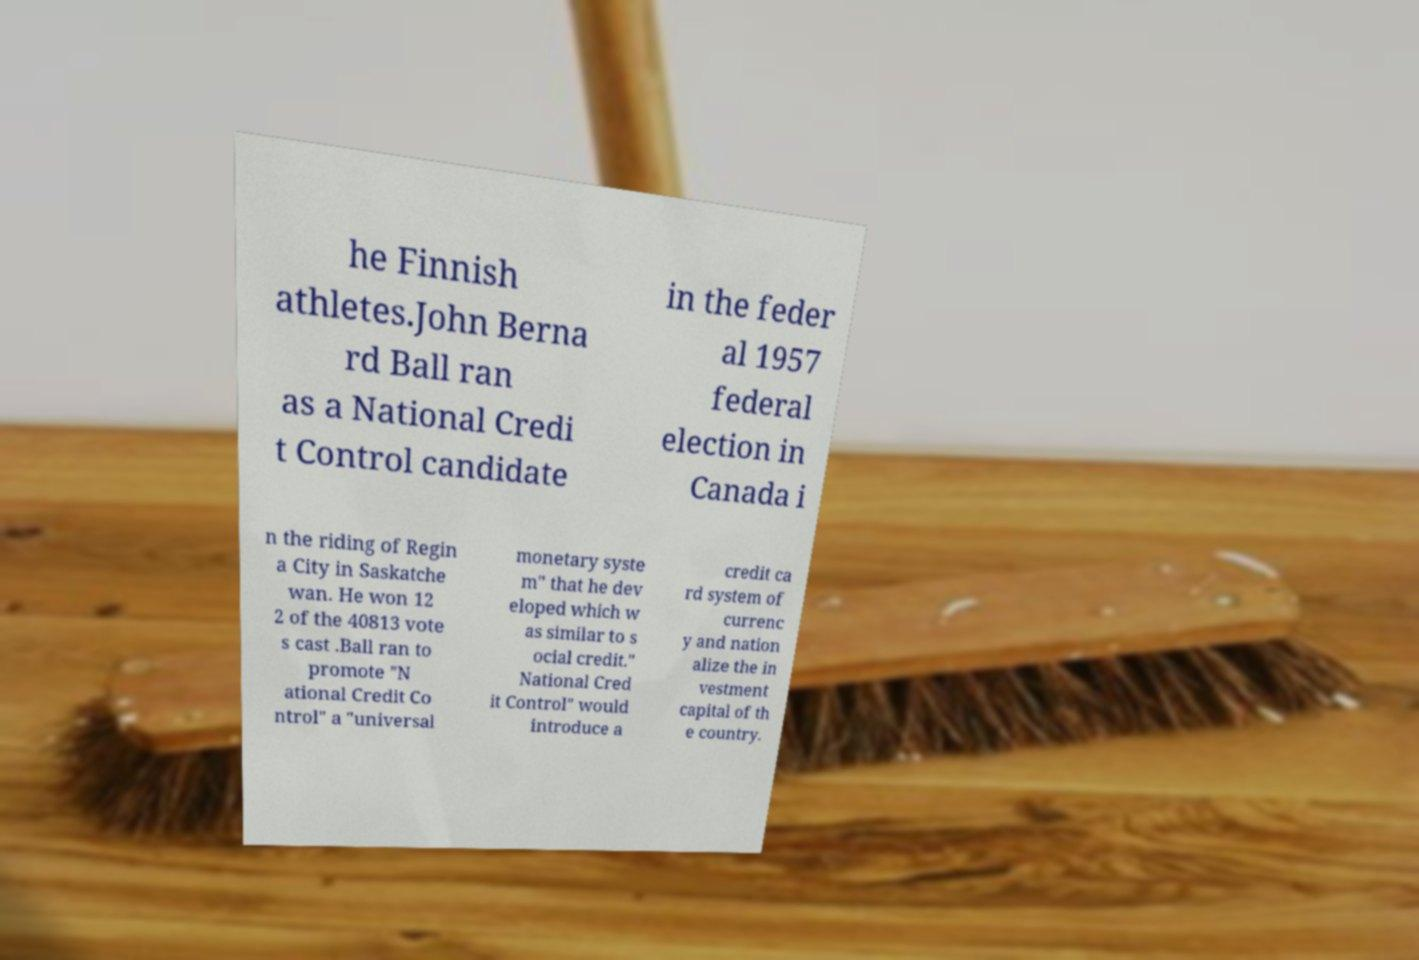There's text embedded in this image that I need extracted. Can you transcribe it verbatim? he Finnish athletes.John Berna rd Ball ran as a National Credi t Control candidate in the feder al 1957 federal election in Canada i n the riding of Regin a City in Saskatche wan. He won 12 2 of the 40813 vote s cast .Ball ran to promote "N ational Credit Co ntrol" a "universal monetary syste m" that he dev eloped which w as similar to s ocial credit." National Cred it Control" would introduce a credit ca rd system of currenc y and nation alize the in vestment capital of th e country. 